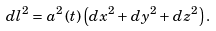Convert formula to latex. <formula><loc_0><loc_0><loc_500><loc_500>d l ^ { 2 } = a ^ { 2 } \, ( t ) \left ( d x ^ { 2 } + d y ^ { 2 } + d z ^ { 2 } \right ) .</formula> 